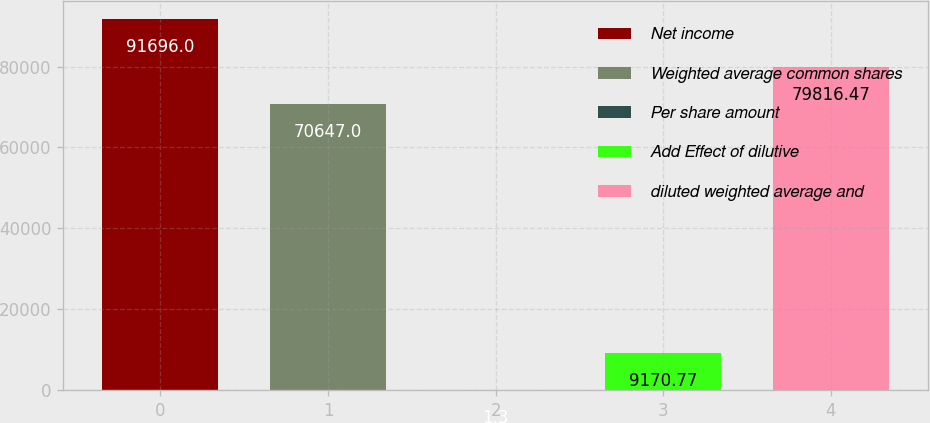Convert chart. <chart><loc_0><loc_0><loc_500><loc_500><bar_chart><fcel>Net income<fcel>Weighted average common shares<fcel>Per share amount<fcel>Add Effect of dilutive<fcel>diluted weighted average and<nl><fcel>91696<fcel>70647<fcel>1.3<fcel>9170.77<fcel>79816.5<nl></chart> 